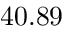<formula> <loc_0><loc_0><loc_500><loc_500>4 0 . 8 9</formula> 